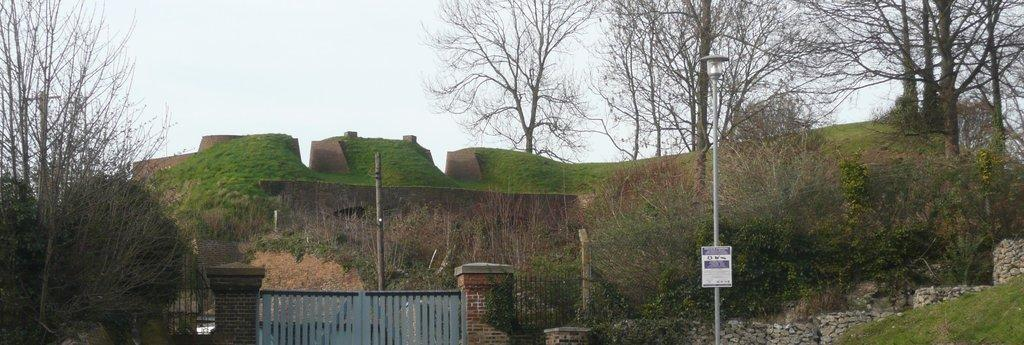What structure can be seen in the image? There is a gate in the image. What is another object visible in the image? There is a pole in the image. What type of natural elements are present in the image? There are stones, trees, and grass visible in the image. What is visible at the top of the image? The sky is visible at the top of the image. What type of development is taking place in the image? There is no indication of any development taking place in the image. Can you tell me how many nuts are present in the image? There is no mention of any nuts in the image. What type of haircut is the tree on the right side of the image getting? There is no indication of any haircut or similar activity involving the trees in the image. 